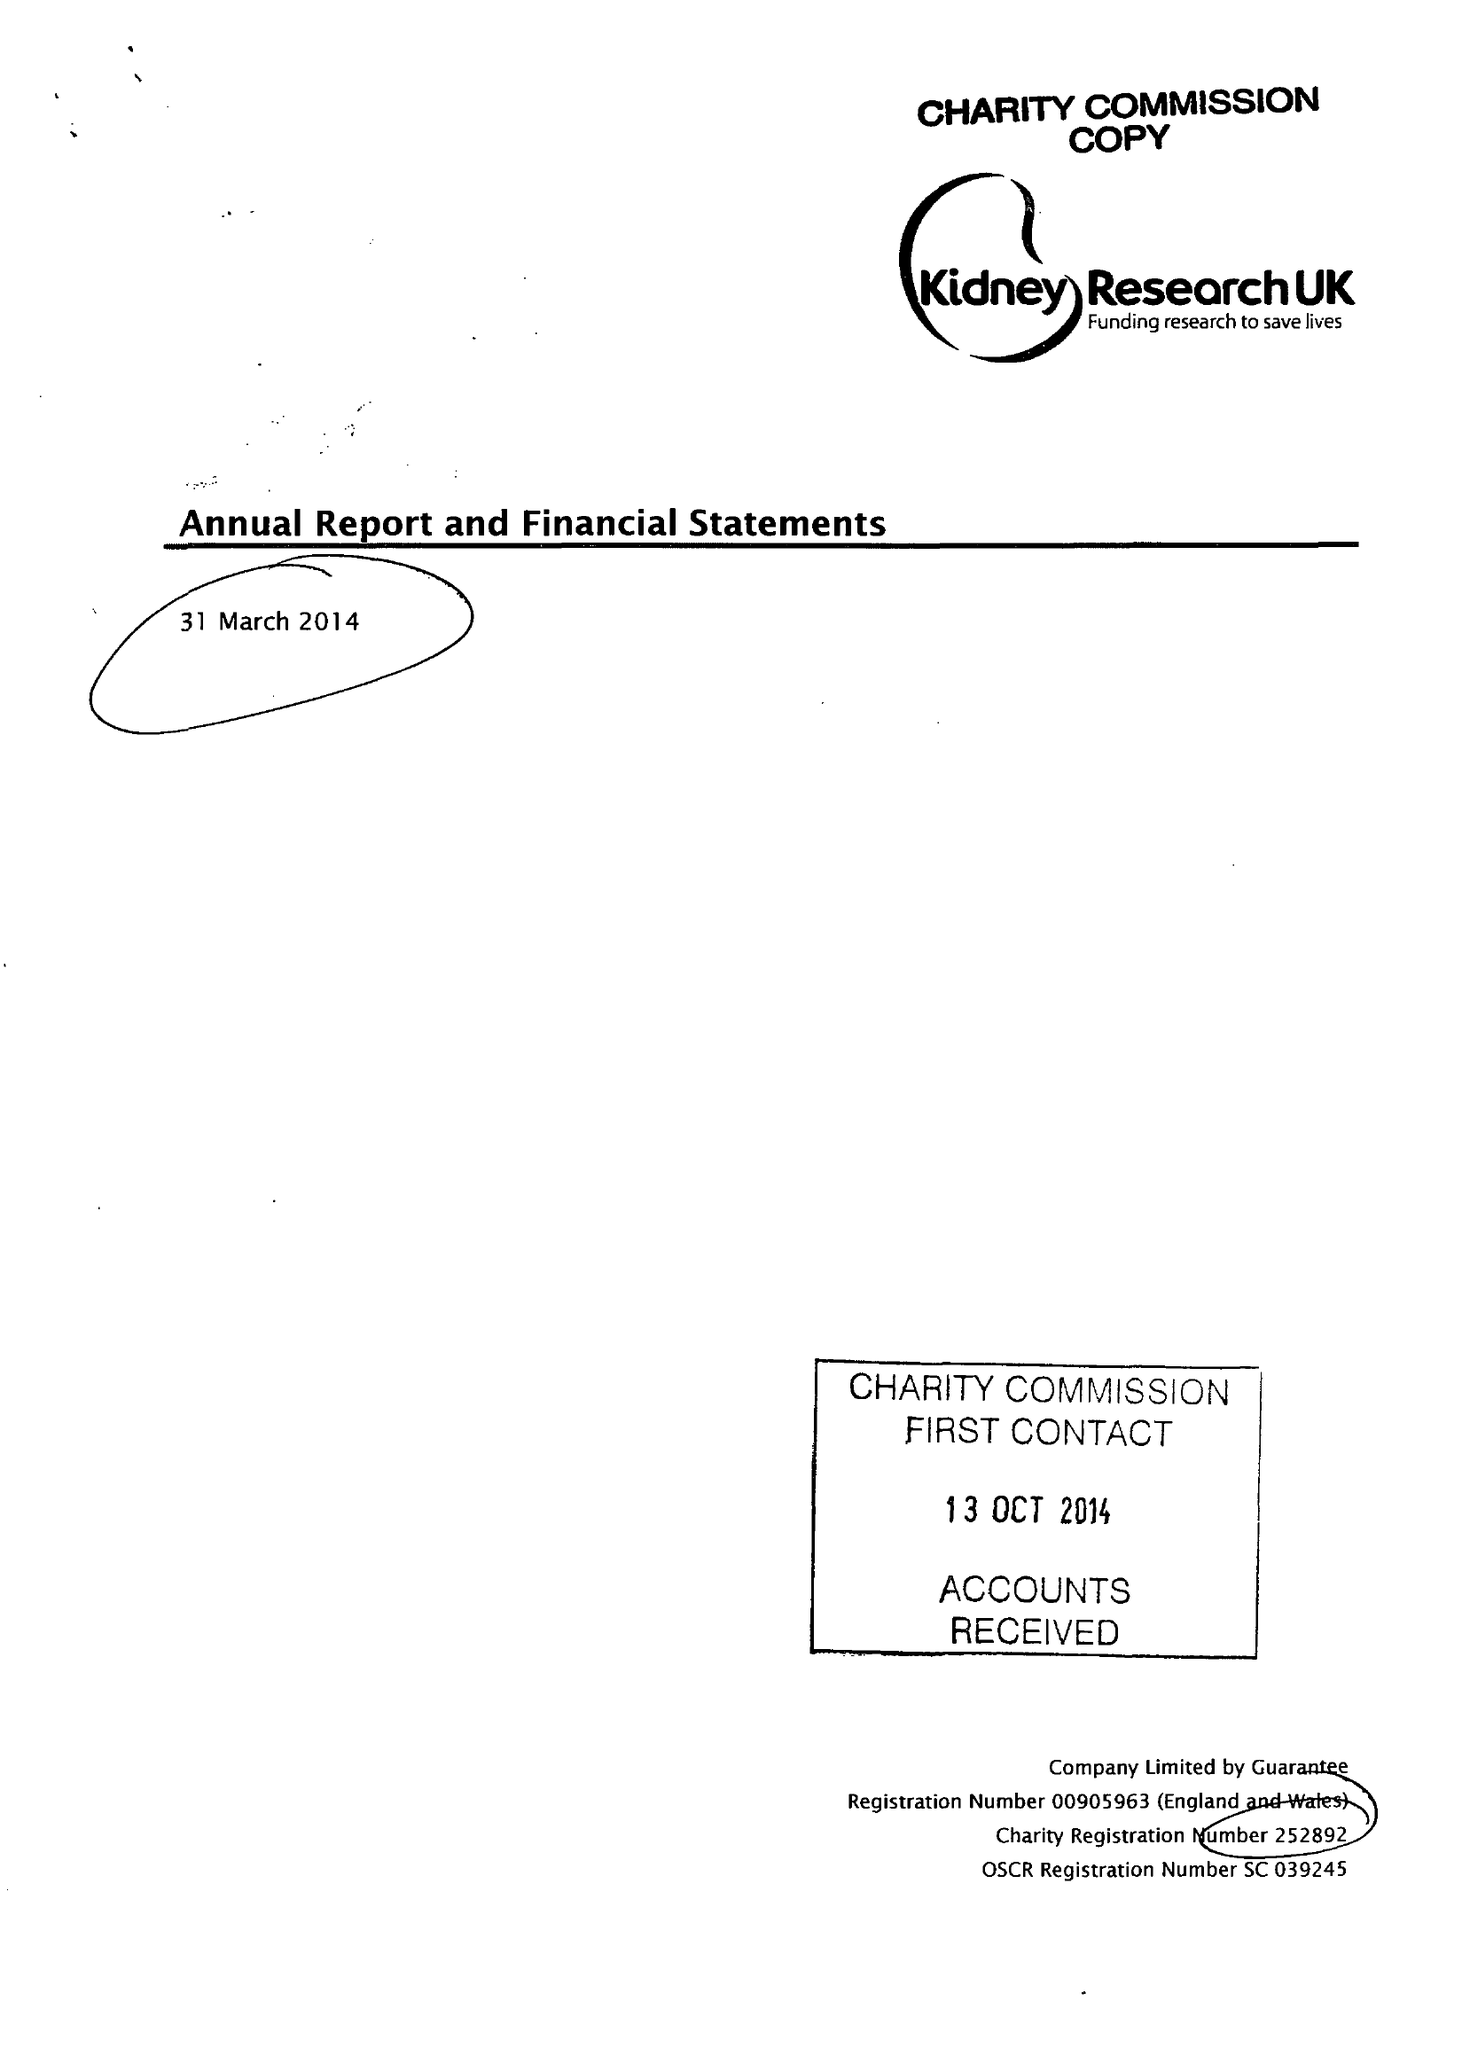What is the value for the address__post_town?
Answer the question using a single word or phrase. PETERBOROUGH 